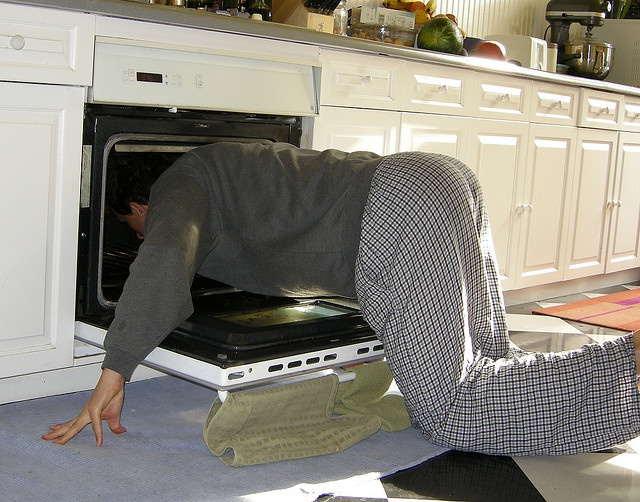Describe the objects in this image and their specific colors. I can see people in gray, black, darkgray, and ivory tones, oven in gray, black, beige, and lightgray tones, orange in gray, brown, and maroon tones, and banana in gray, olive, khaki, and tan tones in this image. 